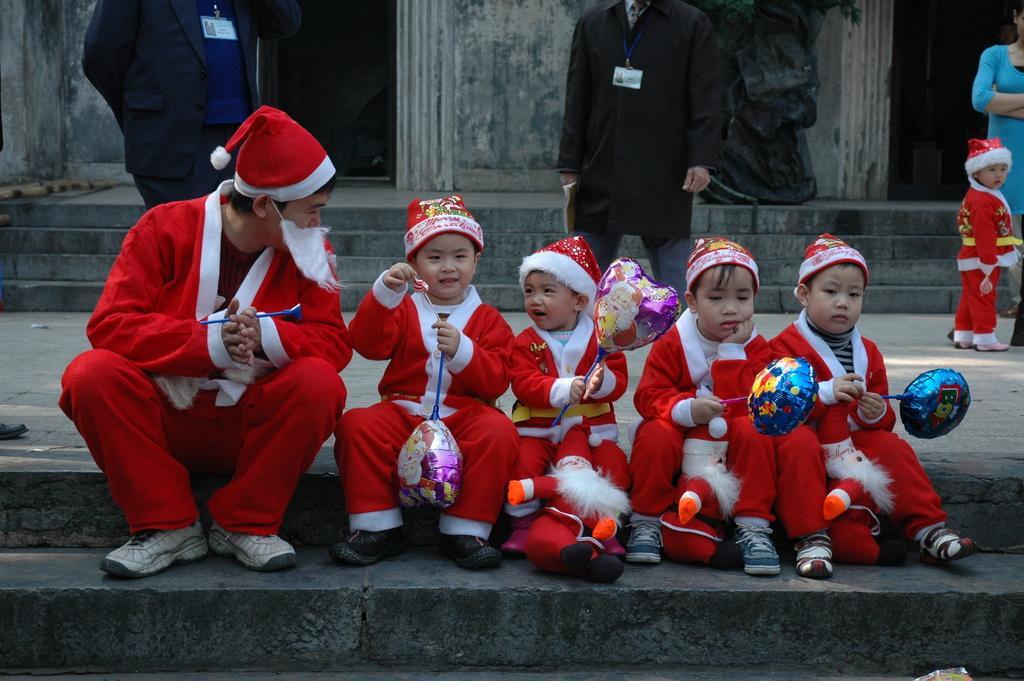In one or two sentences, can you explain what this image depicts? In the image there are few kids and a man with red and white santa claus dresses and holding the toys in their hands. And there are caps on their heads. They are sitting on the steps. Behind them there are few people standing. And there are steps and walls and also there is a black color statue in the background. 